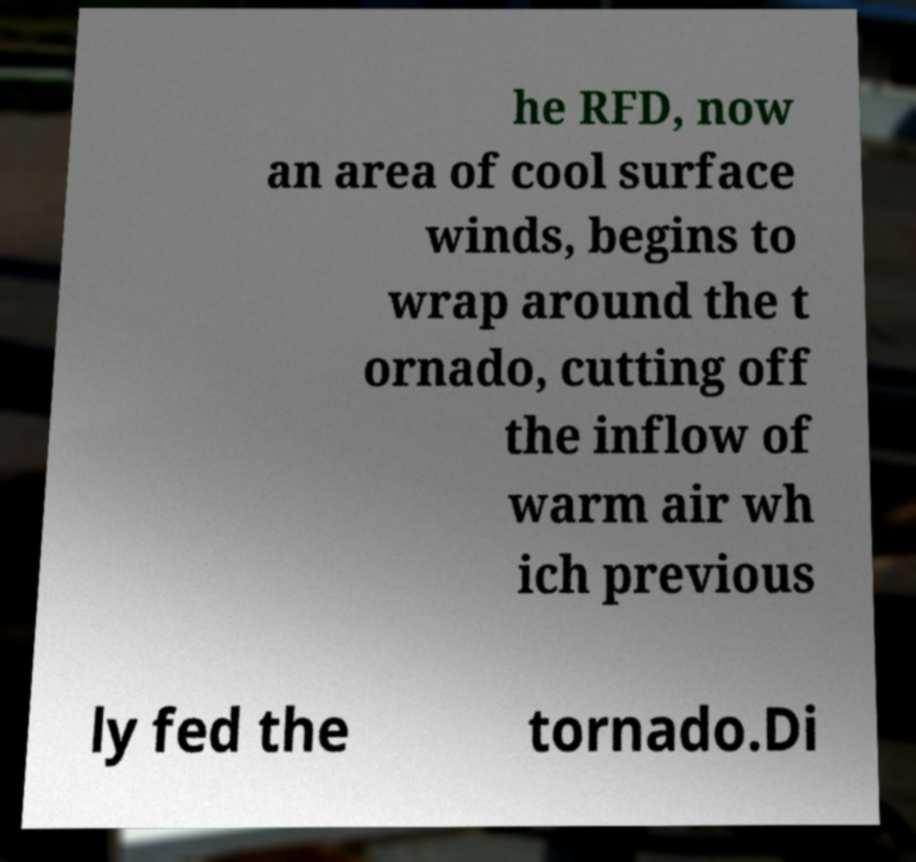What messages or text are displayed in this image? I need them in a readable, typed format. he RFD, now an area of cool surface winds, begins to wrap around the t ornado, cutting off the inflow of warm air wh ich previous ly fed the tornado.Di 